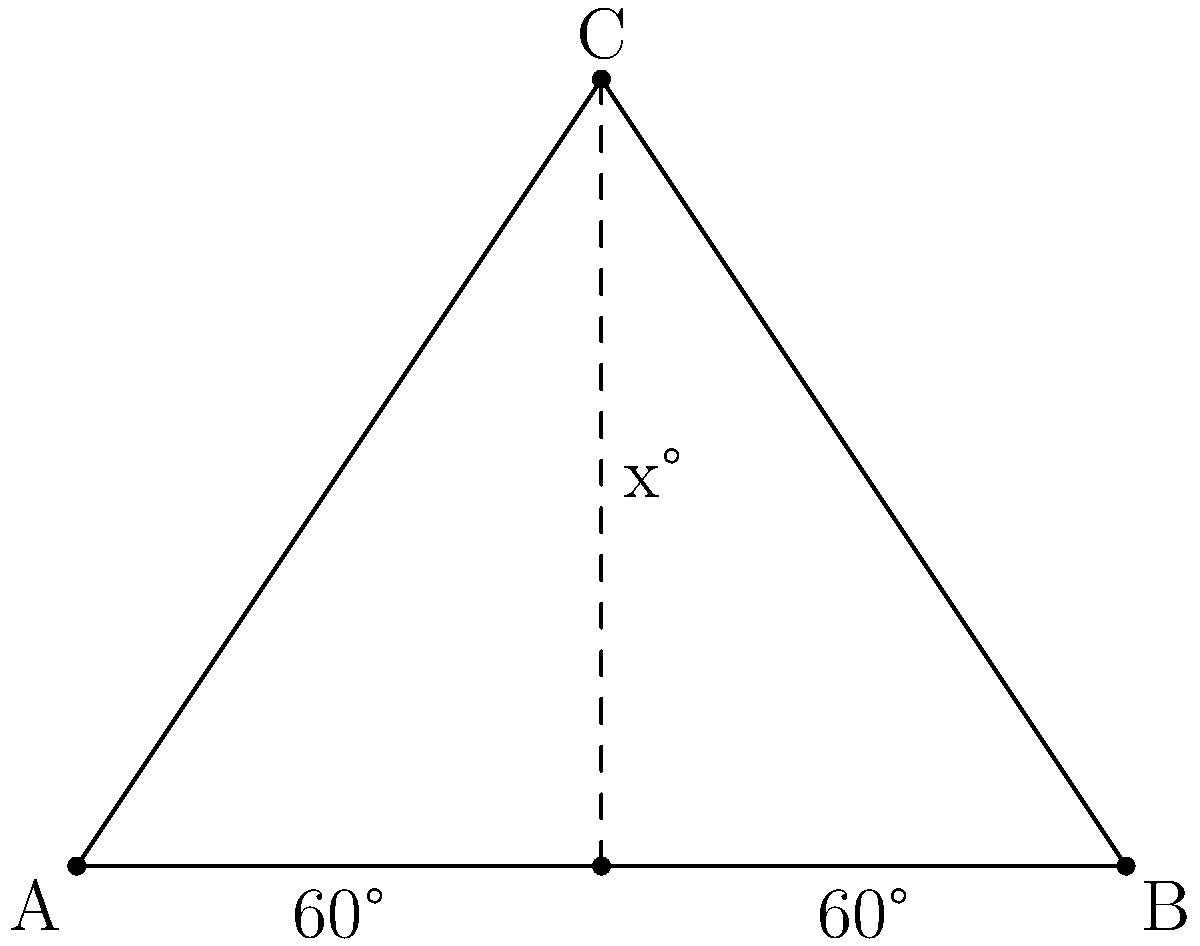In a theater setup, three stage lights form a triangle ABC as shown. The base angles at A and B are both 60°. What is the measure of angle x at the apex C? Let's approach this step-by-step:

1) In any triangle, the sum of all interior angles is always 180°.

2) We are given that the base angles (at A and B) are both 60°.

3) Let's call the angle at C as x°.

4) We can set up an equation:
   $$60° + 60° + x° = 180°$$

5) Simplifying:
   $$120° + x° = 180°$$

6) Subtracting 120° from both sides:
   $$x° = 180° - 120°$$

7) Solving for x:
   $$x° = 60°$$

Therefore, the measure of angle x at the apex C is 60°.
Answer: 60° 